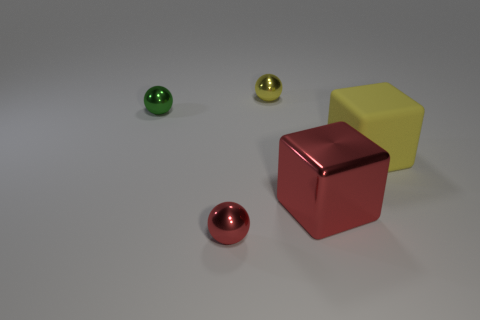Are there any yellow blocks that have the same size as the yellow matte thing? While there are multiple blocks and spherical objects in the image, none of the yellow blocks match the size of the yellow matte sphere exactly. The available yellow block is larger than the yellow sphere. 